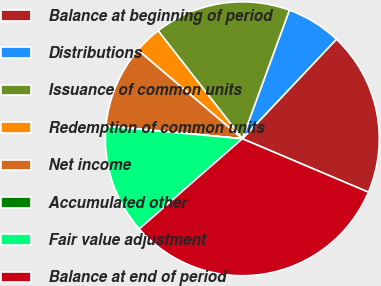Convert chart to OTSL. <chart><loc_0><loc_0><loc_500><loc_500><pie_chart><fcel>Balance at beginning of period<fcel>Distributions<fcel>Issuance of common units<fcel>Redemption of common units<fcel>Net income<fcel>Accumulated other<fcel>Fair value adjustment<fcel>Balance at end of period<nl><fcel>19.33%<fcel>6.47%<fcel>16.12%<fcel>3.26%<fcel>9.69%<fcel>0.05%<fcel>12.9%<fcel>32.18%<nl></chart> 